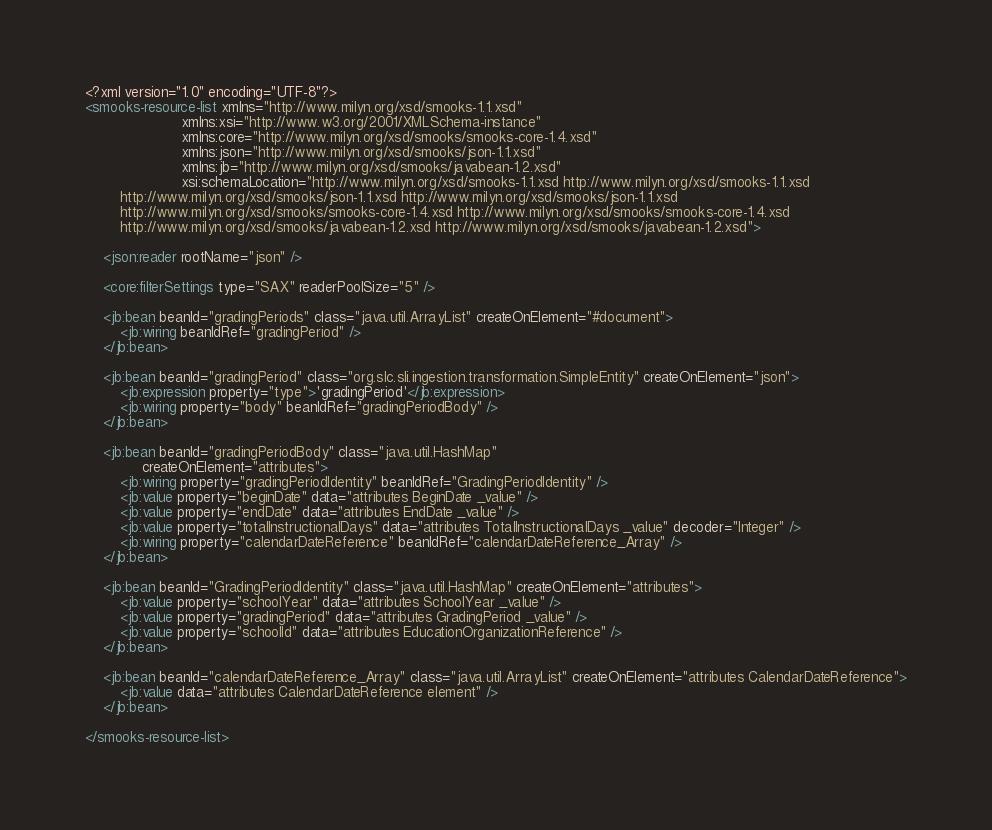Convert code to text. <code><loc_0><loc_0><loc_500><loc_500><_XML_><?xml version="1.0" encoding="UTF-8"?>
<smooks-resource-list xmlns="http://www.milyn.org/xsd/smooks-1.1.xsd"
                      xmlns:xsi="http://www.w3.org/2001/XMLSchema-instance"
                      xmlns:core="http://www.milyn.org/xsd/smooks/smooks-core-1.4.xsd"
                      xmlns:json="http://www.milyn.org/xsd/smooks/json-1.1.xsd"
                      xmlns:jb="http://www.milyn.org/xsd/smooks/javabean-1.2.xsd"
                      xsi:schemaLocation="http://www.milyn.org/xsd/smooks-1.1.xsd http://www.milyn.org/xsd/smooks-1.1.xsd
        http://www.milyn.org/xsd/smooks/json-1.1.xsd http://www.milyn.org/xsd/smooks/json-1.1.xsd
        http://www.milyn.org/xsd/smooks/smooks-core-1.4.xsd http://www.milyn.org/xsd/smooks/smooks-core-1.4.xsd
        http://www.milyn.org/xsd/smooks/javabean-1.2.xsd http://www.milyn.org/xsd/smooks/javabean-1.2.xsd">

    <json:reader rootName="json" />

    <core:filterSettings type="SAX" readerPoolSize="5" />

    <jb:bean beanId="gradingPeriods" class="java.util.ArrayList" createOnElement="#document">
        <jb:wiring beanIdRef="gradingPeriod" />
    </jb:bean>

    <jb:bean beanId="gradingPeriod" class="org.slc.sli.ingestion.transformation.SimpleEntity" createOnElement="json">
        <jb:expression property="type">'gradingPeriod'</jb:expression>
        <jb:wiring property="body" beanIdRef="gradingPeriodBody" />
    </jb:bean>

    <jb:bean beanId="gradingPeriodBody" class="java.util.HashMap"
             createOnElement="attributes">
        <jb:wiring property="gradingPeriodIdentity" beanIdRef="GradingPeriodIdentity" />
        <jb:value property="beginDate" data="attributes BeginDate _value" />
        <jb:value property="endDate" data="attributes EndDate _value" />
        <jb:value property="totalInstructionalDays" data="attributes TotalInstructionalDays _value" decoder="Integer" />
        <jb:wiring property="calendarDateReference" beanIdRef="calendarDateReference_Array" />
    </jb:bean>

    <jb:bean beanId="GradingPeriodIdentity" class="java.util.HashMap" createOnElement="attributes">
        <jb:value property="schoolYear" data="attributes SchoolYear _value" />
        <jb:value property="gradingPeriod" data="attributes GradingPeriod _value" />
        <jb:value property="schoolId" data="attributes EducationOrganizationReference" />
    </jb:bean>

    <jb:bean beanId="calendarDateReference_Array" class="java.util.ArrayList" createOnElement="attributes CalendarDateReference">
        <jb:value data="attributes CalendarDateReference element" />
    </jb:bean>

</smooks-resource-list>
</code> 